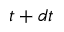<formula> <loc_0><loc_0><loc_500><loc_500>t + d t</formula> 